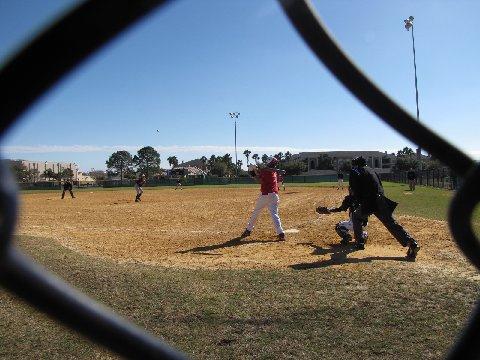Is there clouds in the sky?
Keep it brief. Yes. How many batters do you see?
Be succinct. 1. What game are they playing?
Write a very short answer. Baseball. 